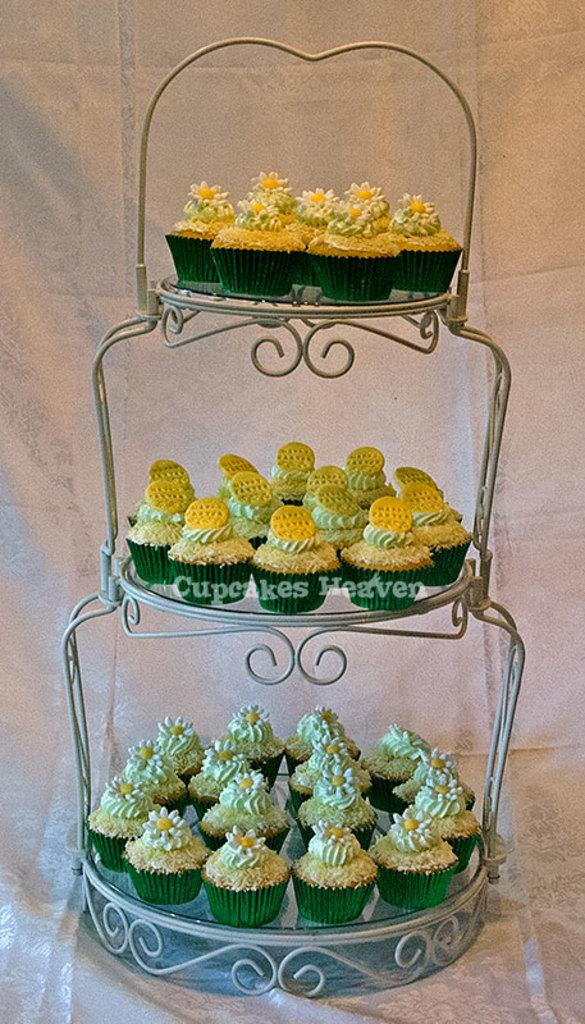What type of dessert can be seen in the image? There are cupcakes in the image. How are the cupcakes arranged or displayed? The cupcakes are placed on a stand. What type of stamp can be seen on the cupcakes in the image? There is no stamp present on the cupcakes in the image. What type of flower is growing next to the cupcakes in the image? There are no flowers present in the image; it only features cupcakes on a stand. 